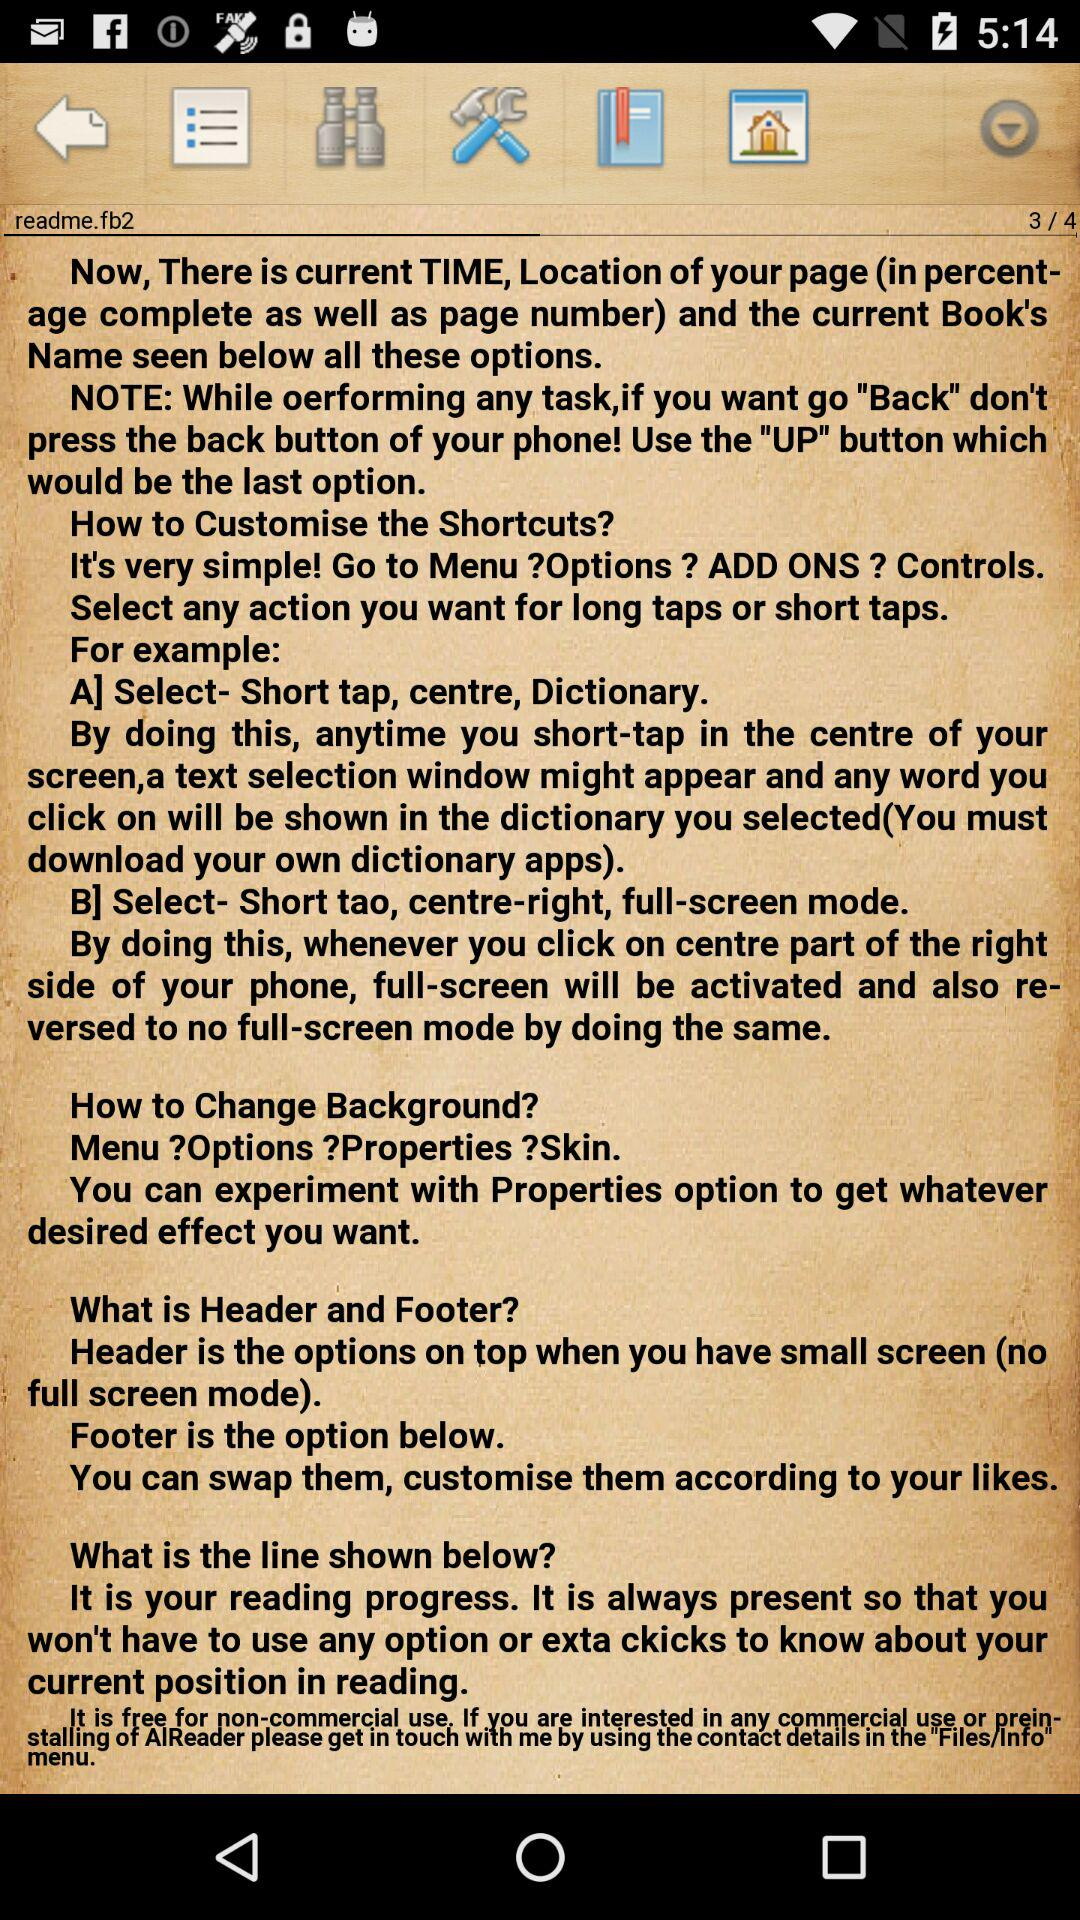How many pages in total are there? There are 4 pages in total. 